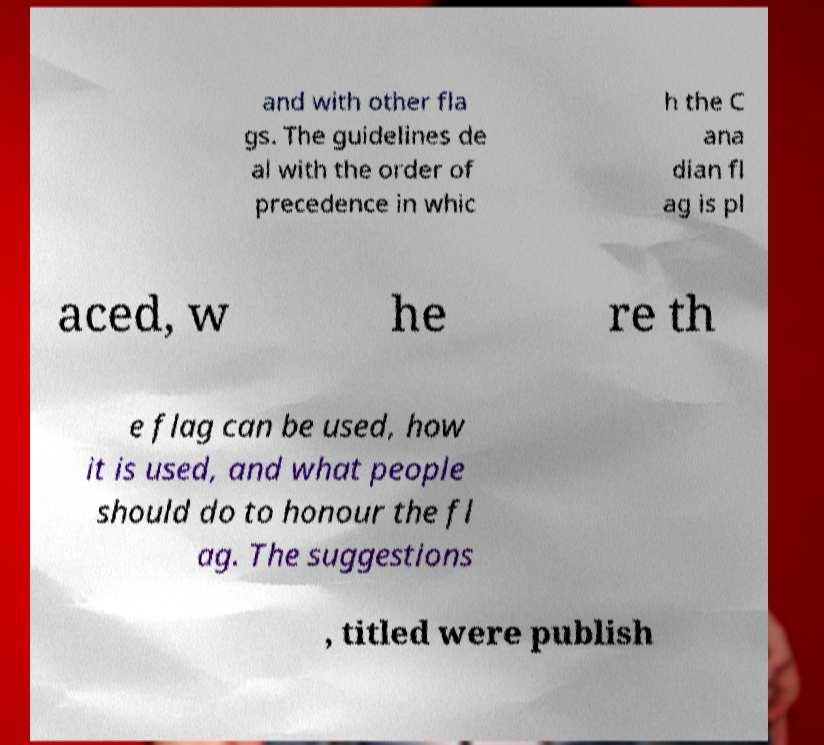Can you read and provide the text displayed in the image?This photo seems to have some interesting text. Can you extract and type it out for me? and with other fla gs. The guidelines de al with the order of precedence in whic h the C ana dian fl ag is pl aced, w he re th e flag can be used, how it is used, and what people should do to honour the fl ag. The suggestions , titled were publish 